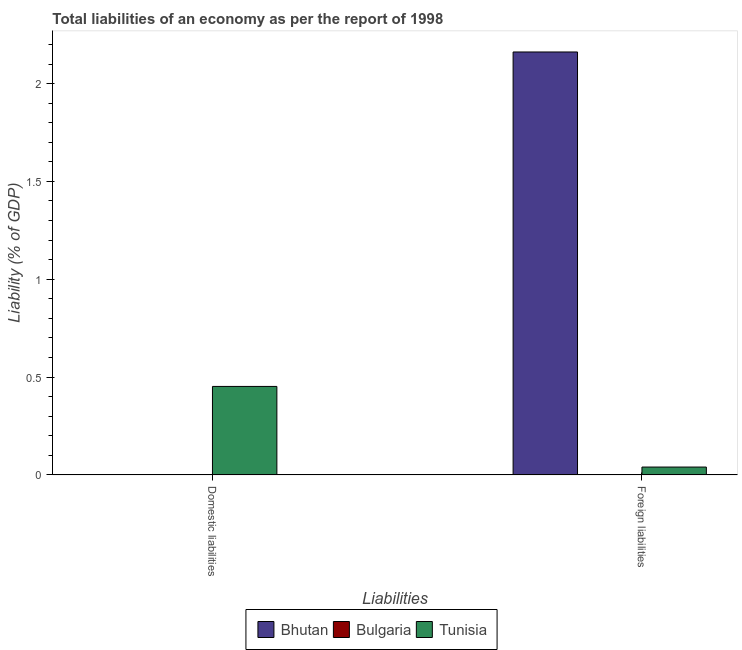How many different coloured bars are there?
Make the answer very short. 2. Are the number of bars per tick equal to the number of legend labels?
Make the answer very short. No. Are the number of bars on each tick of the X-axis equal?
Offer a terse response. No. How many bars are there on the 1st tick from the left?
Give a very brief answer. 1. How many bars are there on the 1st tick from the right?
Make the answer very short. 2. What is the label of the 1st group of bars from the left?
Ensure brevity in your answer.  Domestic liabilities. What is the incurrence of foreign liabilities in Bhutan?
Offer a terse response. 2.16. Across all countries, what is the maximum incurrence of foreign liabilities?
Give a very brief answer. 2.16. Across all countries, what is the minimum incurrence of foreign liabilities?
Give a very brief answer. 0. In which country was the incurrence of domestic liabilities maximum?
Your answer should be compact. Tunisia. What is the total incurrence of foreign liabilities in the graph?
Your answer should be compact. 2.2. What is the difference between the incurrence of foreign liabilities in Tunisia and the incurrence of domestic liabilities in Bhutan?
Your answer should be very brief. 0.04. What is the average incurrence of foreign liabilities per country?
Your response must be concise. 0.73. What is the difference between the incurrence of domestic liabilities and incurrence of foreign liabilities in Tunisia?
Offer a terse response. 0.41. In how many countries, is the incurrence of domestic liabilities greater than 1.6 %?
Give a very brief answer. 0. What is the ratio of the incurrence of foreign liabilities in Tunisia to that in Bhutan?
Your answer should be compact. 0.02. Is the incurrence of foreign liabilities in Tunisia less than that in Bhutan?
Offer a very short reply. Yes. Does the graph contain any zero values?
Give a very brief answer. Yes. Where does the legend appear in the graph?
Your response must be concise. Bottom center. How many legend labels are there?
Provide a succinct answer. 3. What is the title of the graph?
Your answer should be compact. Total liabilities of an economy as per the report of 1998. What is the label or title of the X-axis?
Your answer should be very brief. Liabilities. What is the label or title of the Y-axis?
Your response must be concise. Liability (% of GDP). What is the Liability (% of GDP) in Bhutan in Domestic liabilities?
Provide a short and direct response. 0. What is the Liability (% of GDP) in Tunisia in Domestic liabilities?
Offer a very short reply. 0.45. What is the Liability (% of GDP) in Bhutan in Foreign liabilities?
Offer a terse response. 2.16. What is the Liability (% of GDP) of Tunisia in Foreign liabilities?
Your answer should be very brief. 0.04. Across all Liabilities, what is the maximum Liability (% of GDP) of Bhutan?
Offer a very short reply. 2.16. Across all Liabilities, what is the maximum Liability (% of GDP) in Tunisia?
Your answer should be compact. 0.45. Across all Liabilities, what is the minimum Liability (% of GDP) of Tunisia?
Your response must be concise. 0.04. What is the total Liability (% of GDP) of Bhutan in the graph?
Give a very brief answer. 2.16. What is the total Liability (% of GDP) of Bulgaria in the graph?
Provide a succinct answer. 0. What is the total Liability (% of GDP) of Tunisia in the graph?
Provide a short and direct response. 0.49. What is the difference between the Liability (% of GDP) in Tunisia in Domestic liabilities and that in Foreign liabilities?
Keep it short and to the point. 0.41. What is the average Liability (% of GDP) of Bhutan per Liabilities?
Keep it short and to the point. 1.08. What is the average Liability (% of GDP) of Bulgaria per Liabilities?
Keep it short and to the point. 0. What is the average Liability (% of GDP) of Tunisia per Liabilities?
Your answer should be compact. 0.25. What is the difference between the Liability (% of GDP) in Bhutan and Liability (% of GDP) in Tunisia in Foreign liabilities?
Ensure brevity in your answer.  2.12. What is the ratio of the Liability (% of GDP) of Tunisia in Domestic liabilities to that in Foreign liabilities?
Keep it short and to the point. 11.23. What is the difference between the highest and the second highest Liability (% of GDP) in Tunisia?
Provide a succinct answer. 0.41. What is the difference between the highest and the lowest Liability (% of GDP) in Bhutan?
Provide a succinct answer. 2.16. What is the difference between the highest and the lowest Liability (% of GDP) of Tunisia?
Offer a terse response. 0.41. 